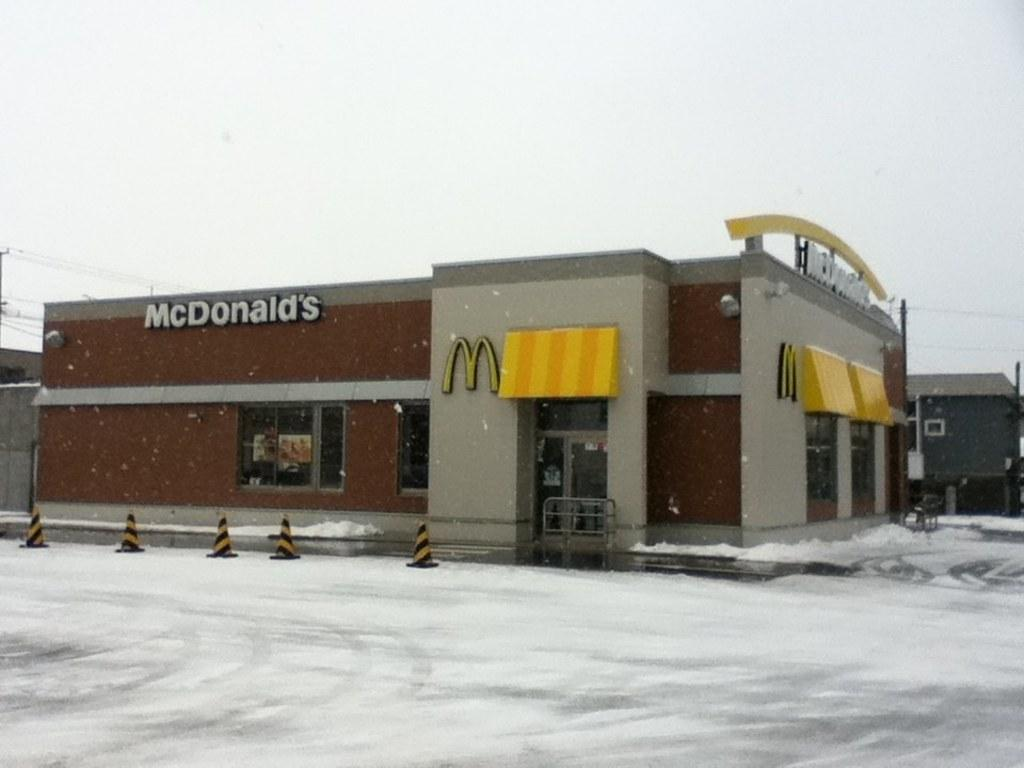What is the main subject in the image? There is a place in the image. What is the condition of the road in front of the place? The road in front of the place is covered with ice. What advice is being given to the place in the image? There is no advice being given in the image; it is a static representation of a place with an icy road. What thought is being expressed by the place in the image? There is no thought being expressed by the place in the image; it is an inanimate object. 